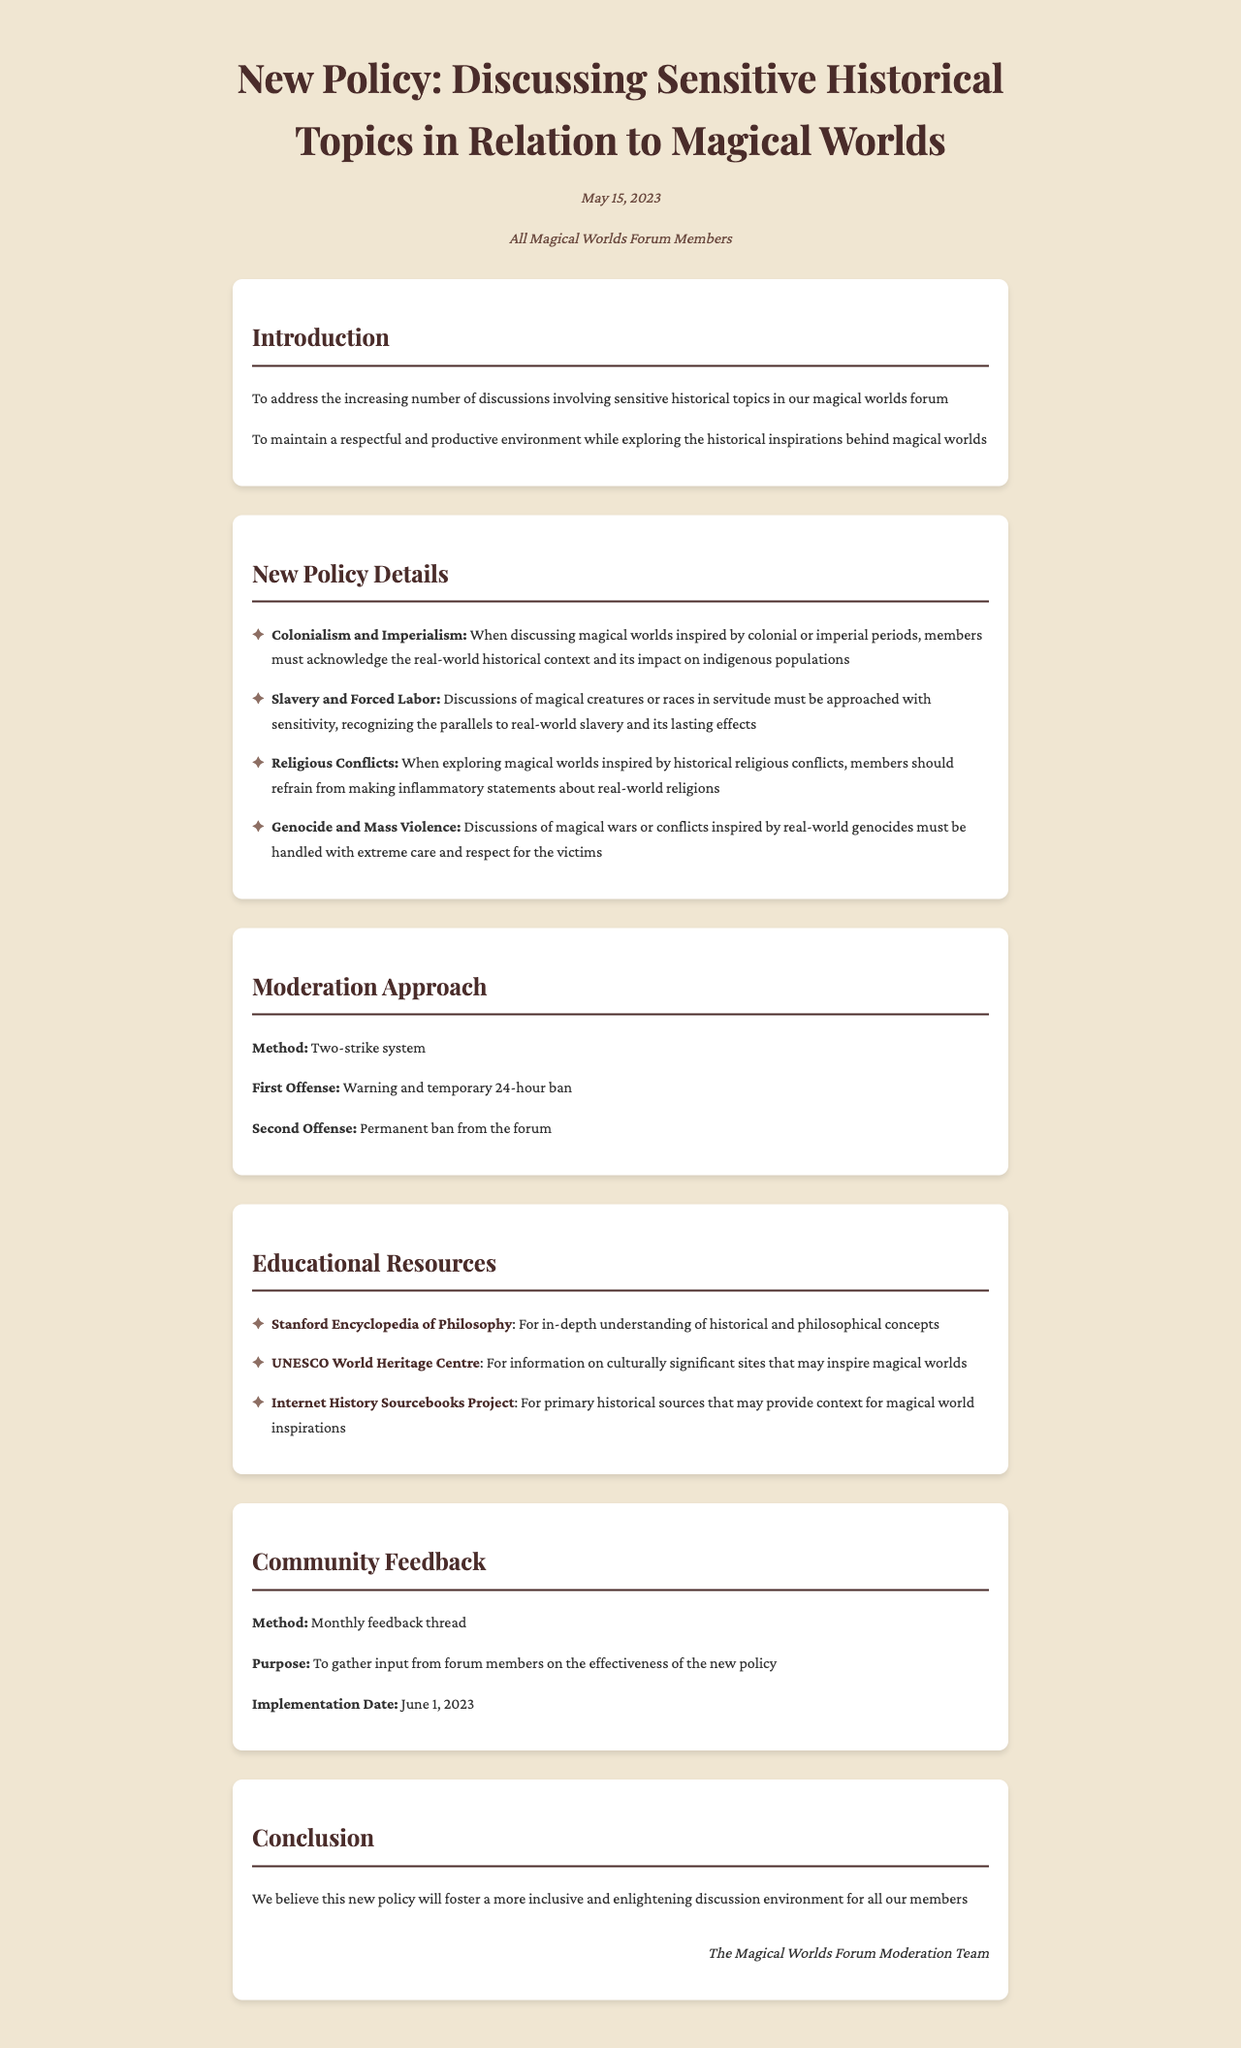What is the date of the letter? The date is specified in the letter header section of the document.
Answer: May 15, 2023 Who is the recipient of the letter? The recipient is mentioned in the letter header, indicating the target audience for the communication.
Answer: All Magical Worlds Forum Members What is the new policy topic related to slavery? The document lists several sensitive historical topics with associated guidelines.
Answer: Discussions of magical creatures or races in servitude What is the moderation method outlined in the document? The moderation approach section states a specific method to be followed for enforcing the new policies.
Answer: Two-strike system What is the implementation date for community feedback? The implementation date is provided in the community feedback section to indicate when members can start providing feedback.
Answer: June 1, 2023 What is the first offense penalty according to the document? The new policy explains consequences for offenses in its moderation approach section.
Answer: Warning and temporary 24-hour ban What educational resource focuses on primary historical sources? The educational resources section lists various sources for further reading, including primary sources.
Answer: Internet History Sourcebooks Project What is the main goal of the policy? The goal is stated clearly in the introduction section and highlights the intent behind the policy's creation.
Answer: To maintain a respectful and productive environment How often will feedback be gathered from the community? The community feedback section specifies a method for collecting input from members, relevant to the policy.
Answer: Monthly feedback thread 